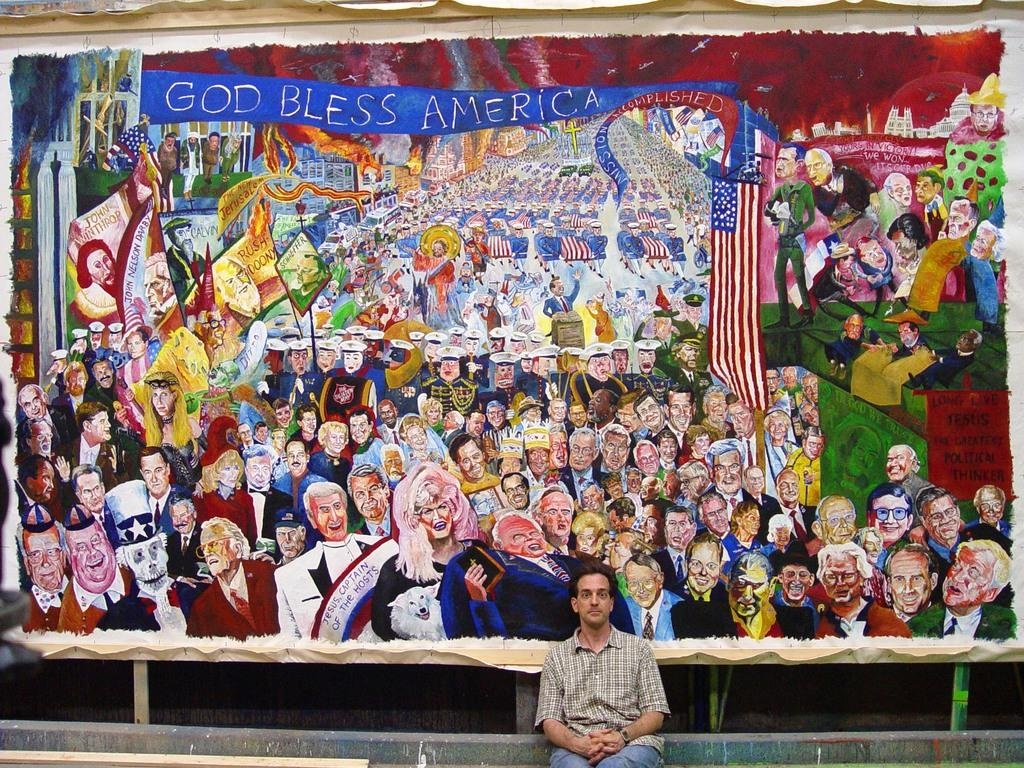Who or what is present in the image? There is a person in the image. What is the person doing in the image? The person is sitting. What is the person wearing in the image? The person is wearing clothes. What can be seen in the background of the image? There is a hoarding in the image, which contains an art piece. What type of shoes is the person wearing in the image? The provided facts do not mention shoes, so we cannot determine the type of shoes the person is wearing in the image. 